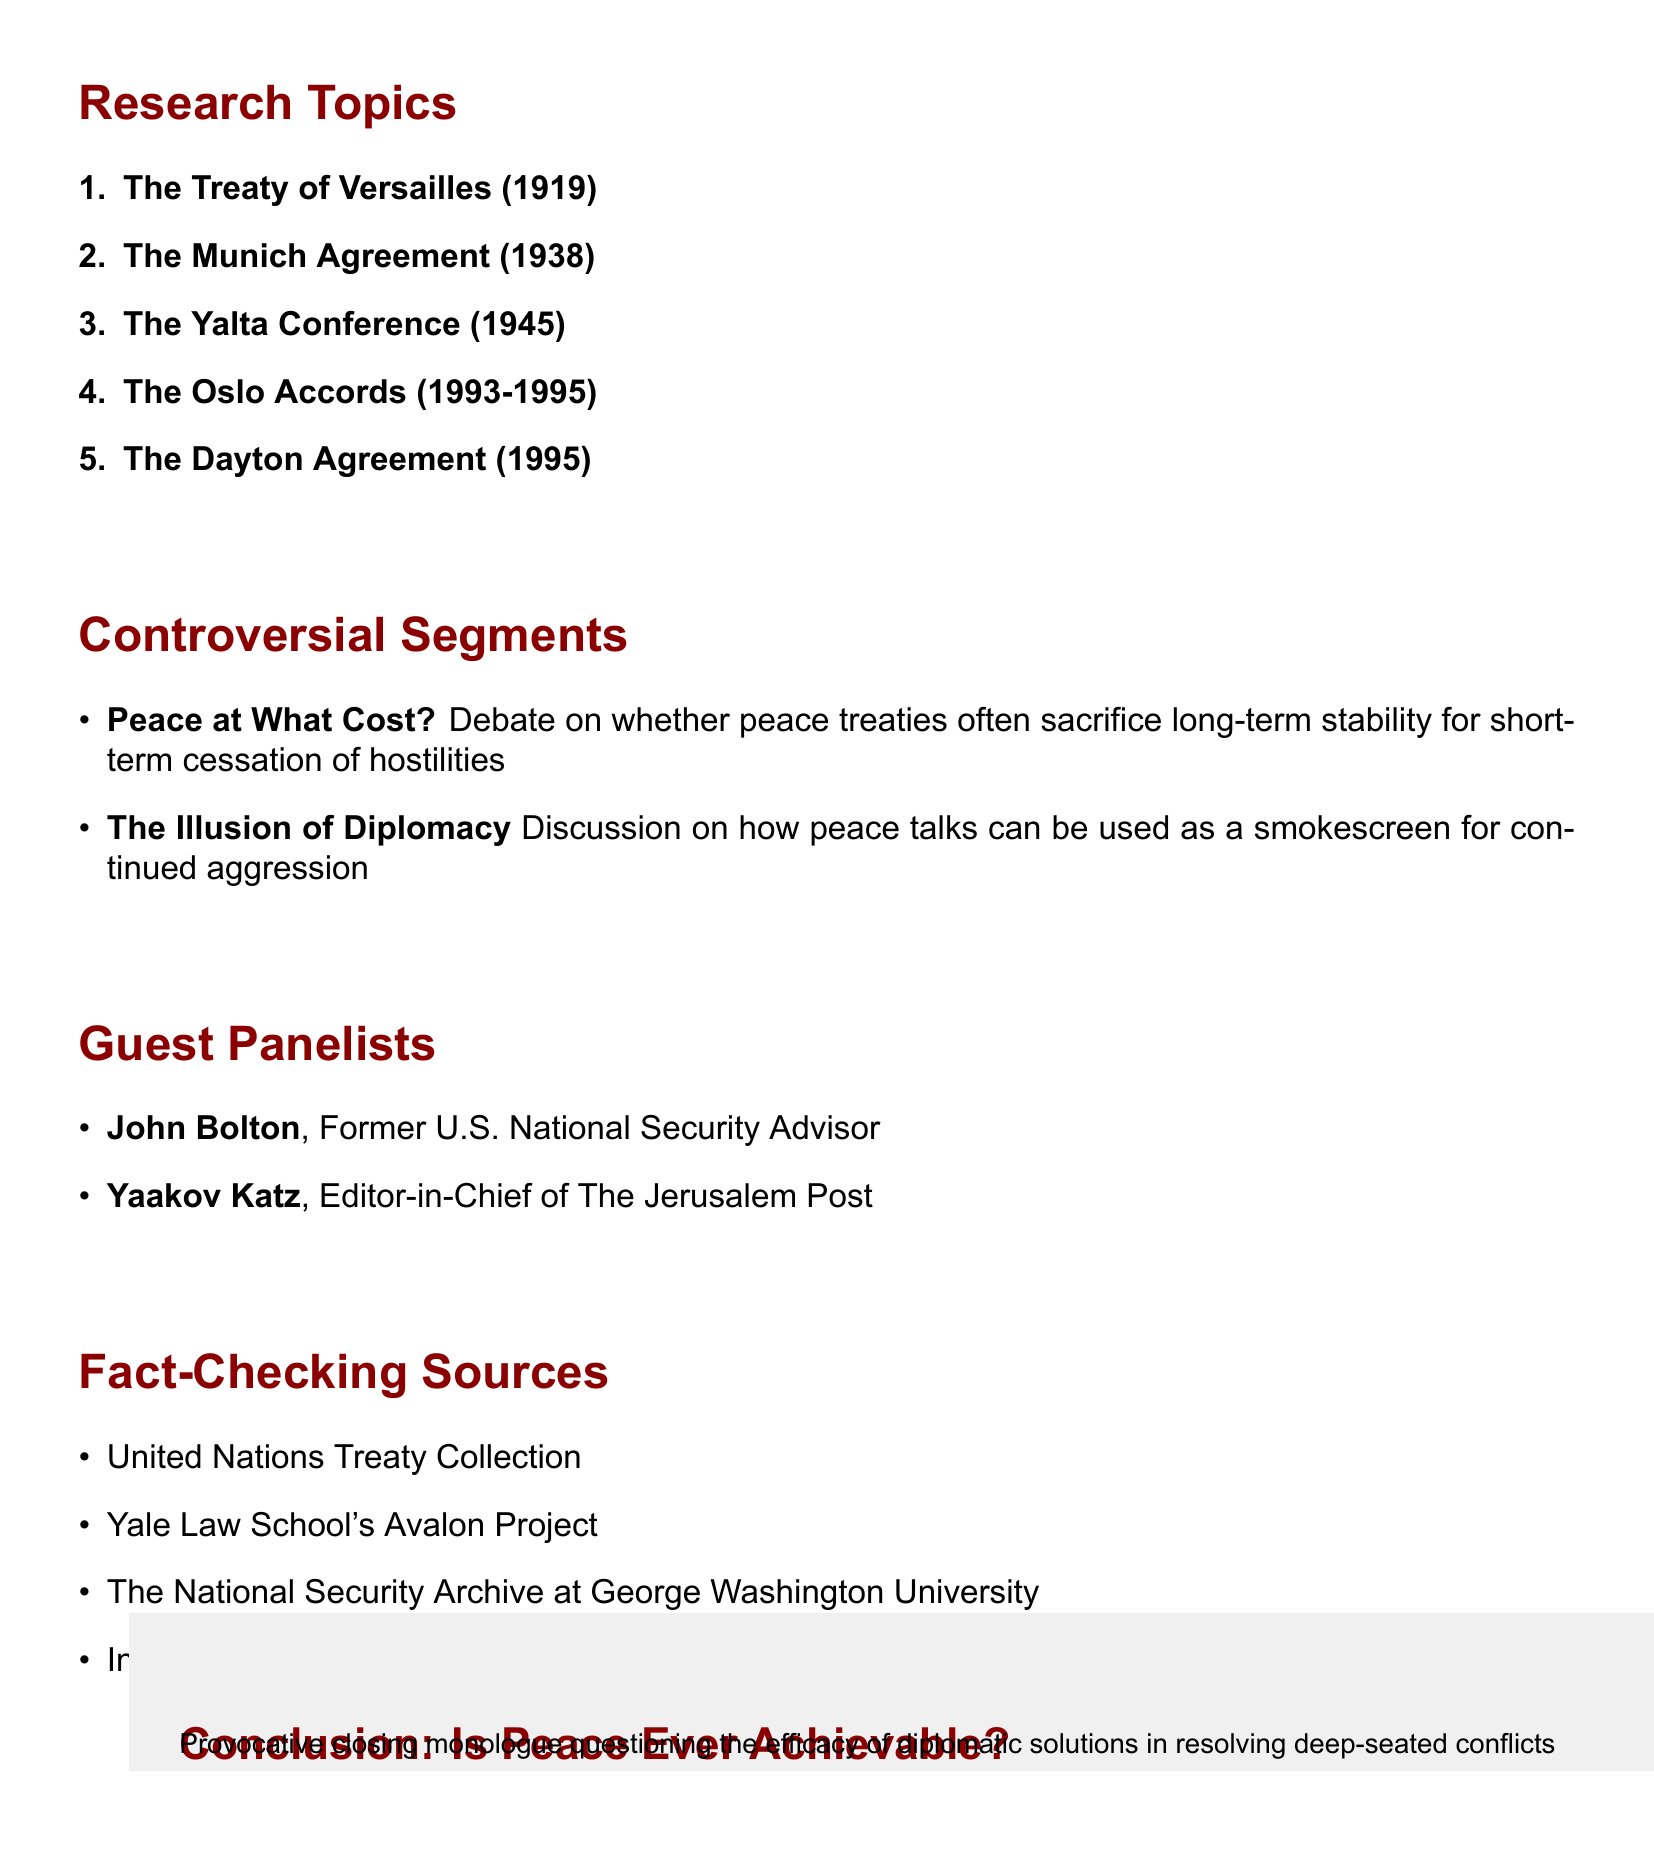What is the title of the talk show? The title of the talk show is at the beginning of the document.
Answer: Peace Talks: A Path to Nowhere? Who is the host of the talk show? The host's name is mentioned prominently at the top of the document.
Answer: Tucker Carlson How many research topics are listed? The number of research topics can be counted in the respective section of the document.
Answer: Five Which expert will discuss the Oslo Accords? The expert for the Oslo Accords is specified in the research topics.
Answer: Dr. Rashid Khalidi What does the segment "Peace at What Cost?" focus on? The description of the segment outlines its focus thoroughly in the document.
Answer: Peace treaties and long-term stability What year was the Dayton Agreement signed? The year is mentioned alongside the title of the research topic in the document.
Answer: 1995 Which institution is Dr. Margaret MacMillan affiliated with? The affiliation of Dr. MacMillan is directly noted next to her name in the document.
Answer: Oxford University How many guest panelists are there? The number of guest panelists can be derived from their listing in the document.
Answer: Two What is the subject of the conclusion segment? The subject of the conclusion segment is clearly stated at the end of the document.
Answer: Is Peace Ever Achievable? 